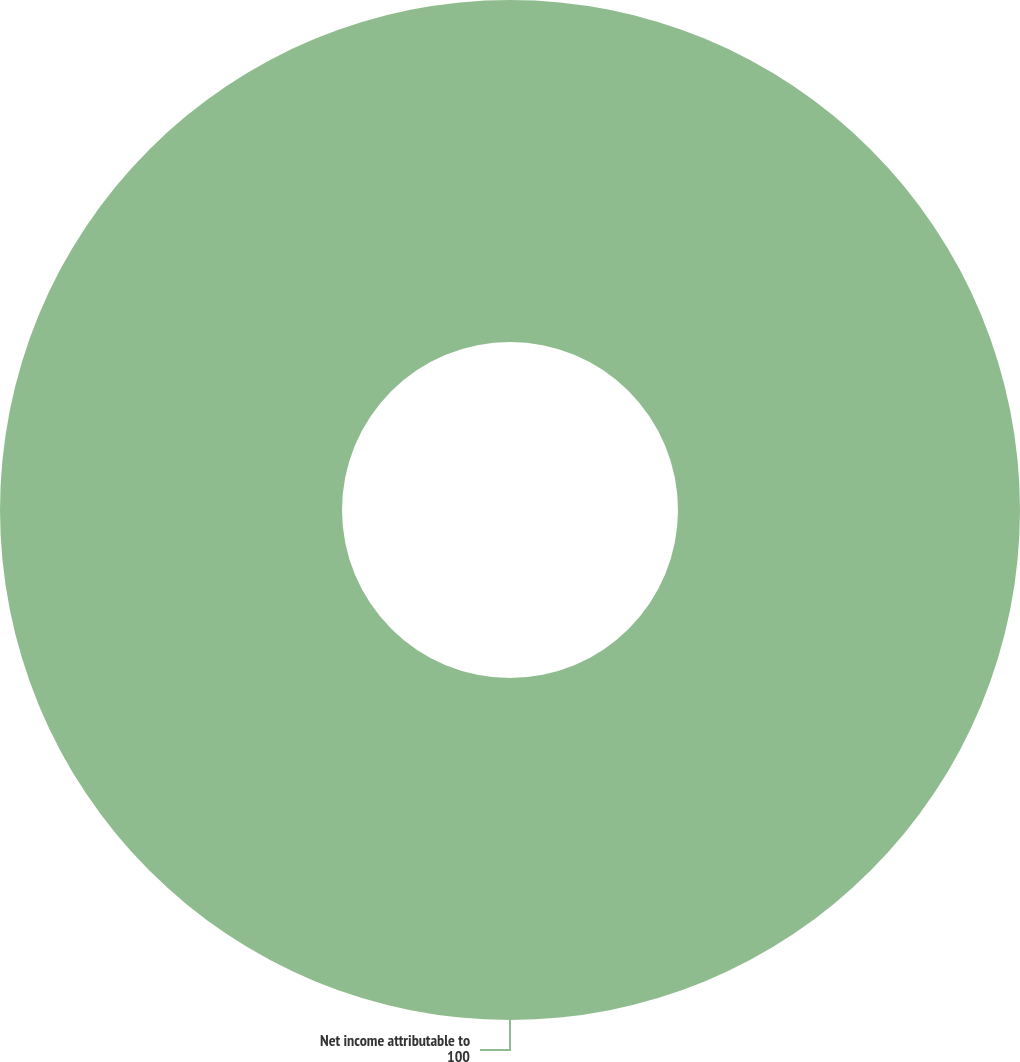<chart> <loc_0><loc_0><loc_500><loc_500><pie_chart><fcel>Net income attributable to<nl><fcel>100.0%<nl></chart> 